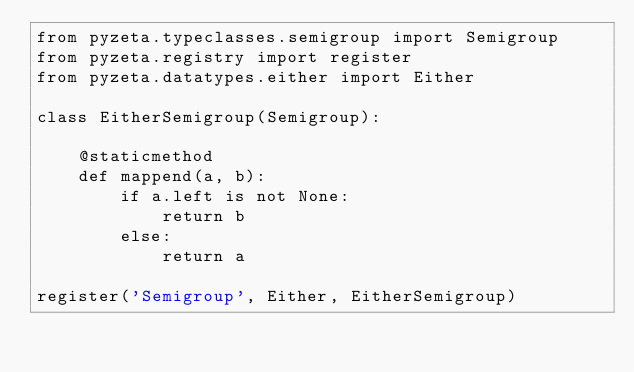<code> <loc_0><loc_0><loc_500><loc_500><_Python_>from pyzeta.typeclasses.semigroup import Semigroup
from pyzeta.registry import register
from pyzeta.datatypes.either import Either

class EitherSemigroup(Semigroup):

    @staticmethod
    def mappend(a, b):
        if a.left is not None:
            return b
        else:
            return a

register('Semigroup', Either, EitherSemigroup)
</code> 